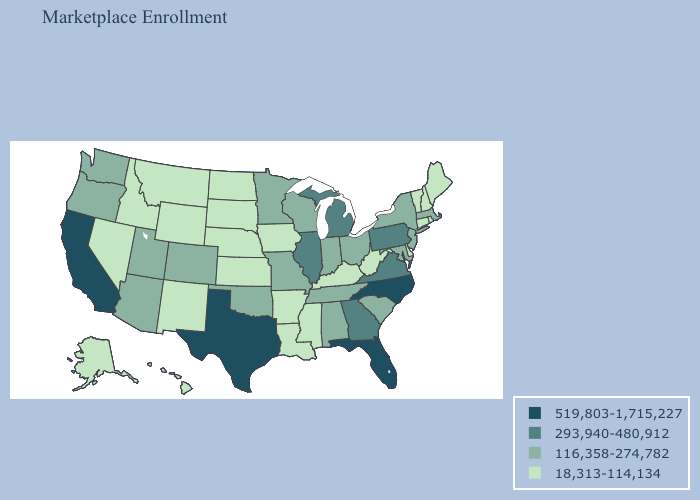Name the states that have a value in the range 519,803-1,715,227?
Answer briefly. California, Florida, North Carolina, Texas. What is the lowest value in states that border Kentucky?
Write a very short answer. 18,313-114,134. Which states have the highest value in the USA?
Be succinct. California, Florida, North Carolina, Texas. What is the highest value in states that border California?
Keep it brief. 116,358-274,782. Name the states that have a value in the range 519,803-1,715,227?
Give a very brief answer. California, Florida, North Carolina, Texas. What is the highest value in the USA?
Write a very short answer. 519,803-1,715,227. Name the states that have a value in the range 293,940-480,912?
Answer briefly. Georgia, Illinois, Michigan, Pennsylvania, Virginia. Does Vermont have a higher value than North Dakota?
Write a very short answer. No. Name the states that have a value in the range 18,313-114,134?
Concise answer only. Alaska, Arkansas, Connecticut, Delaware, Hawaii, Idaho, Iowa, Kansas, Kentucky, Louisiana, Maine, Mississippi, Montana, Nebraska, Nevada, New Hampshire, New Mexico, North Dakota, Rhode Island, South Dakota, Vermont, West Virginia, Wyoming. How many symbols are there in the legend?
Concise answer only. 4. Among the states that border Colorado , does Arizona have the highest value?
Answer briefly. Yes. What is the lowest value in the West?
Write a very short answer. 18,313-114,134. Which states have the highest value in the USA?
Be succinct. California, Florida, North Carolina, Texas. Does New York have the lowest value in the USA?
Be succinct. No. Which states have the lowest value in the Northeast?
Answer briefly. Connecticut, Maine, New Hampshire, Rhode Island, Vermont. 